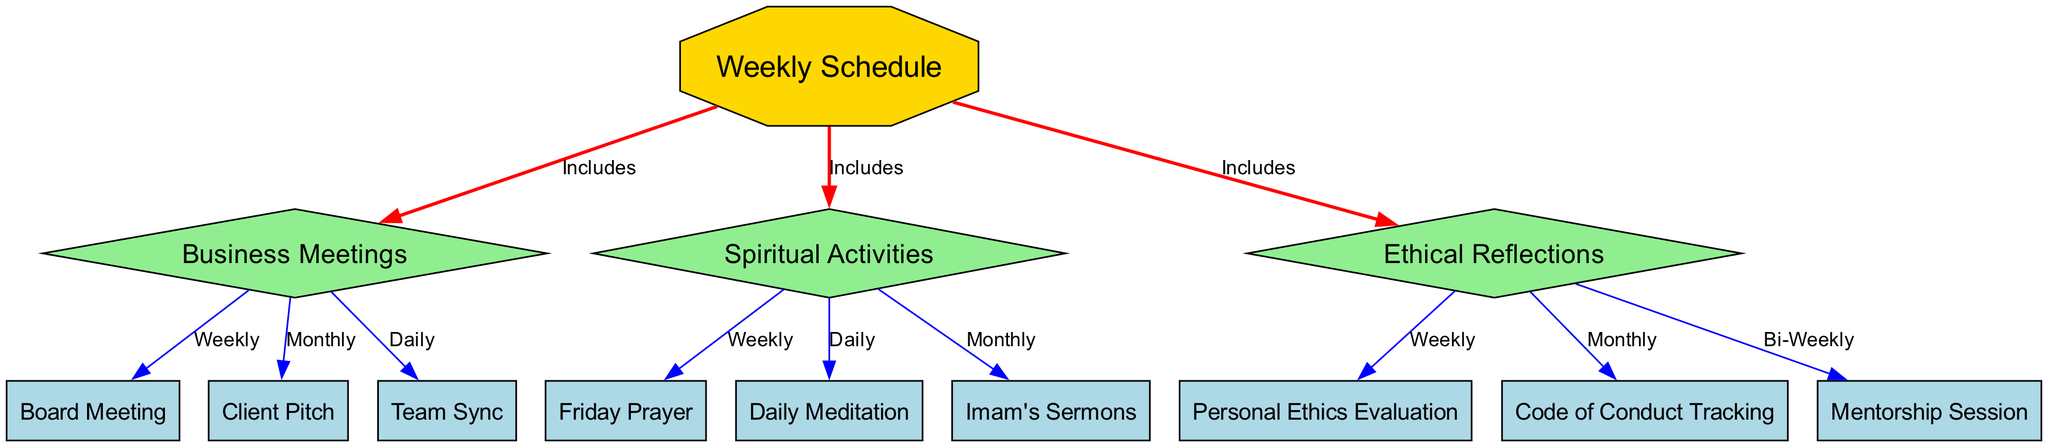What are the three main components of the weekly schedule? The diagram shows three main components connected to the "Weekly Schedule" node: "Business Meetings", "Spiritual Activities", and "Ethical Reflections".
Answer: Business Meetings, Spiritual Activities, Ethical Reflections How many weekly meetings are included in the business meetings section? In the diagram, there is one edge labeled "Weekly" connecting the "Business Meetings" node to the "Board Meeting" node, indicating there is one weekly meeting.
Answer: 1 What is the frequency of the Daily Meditation activity? Examining the connection from "Spiritual Activities" to "Daily Meditation", the diagram indicates a "Daily" frequency for this activity.
Answer: Daily How often are Ethical Reflections evaluated according to the diagram? The "Ethical Reflections" node connects to the "Personal Ethics Evaluation" node with an edge labeled "Weekly", indicating that ethical evaluations occur weekly.
Answer: Weekly What type of node is the Weekly Schedule? The "Weekly Schedule" node is displayed as an octagon shape, which is distinct from the diamond shapes of the other main components.
Answer: Octagon How many monthly activities are associated with Spiritual Activities? The diagram shows one edge labeled "Monthly" connecting "Spiritual Activities" to "Imam's Sermons," indicating there is one monthly activity.
Answer: 1 Which activity is conducted bi-weekly in the ethical reflections section? By looking at the "Ethical Reflections" node, it connects to the "Mentorship Session" with an edge labeled "Bi-Weekly," signifying that this particular activity is conducted bi-weekly.
Answer: Mentorship Session What is the connection between Business Meetings and Team Sync? The diagram connects "Business Meetings" to "Team Sync" with an edge labeled "Daily", indicating that team sync meetings are held daily under business operations.
Answer: Daily Which aspect of the schedule includes Daily activities? Upon reviewing the connections, both "Daily Meditation" and "Team Sync" are part of the activities included in the "Spiritual Activities" and "Business Meetings" sections, respectively.
Answer: Team Sync, Daily Meditation 